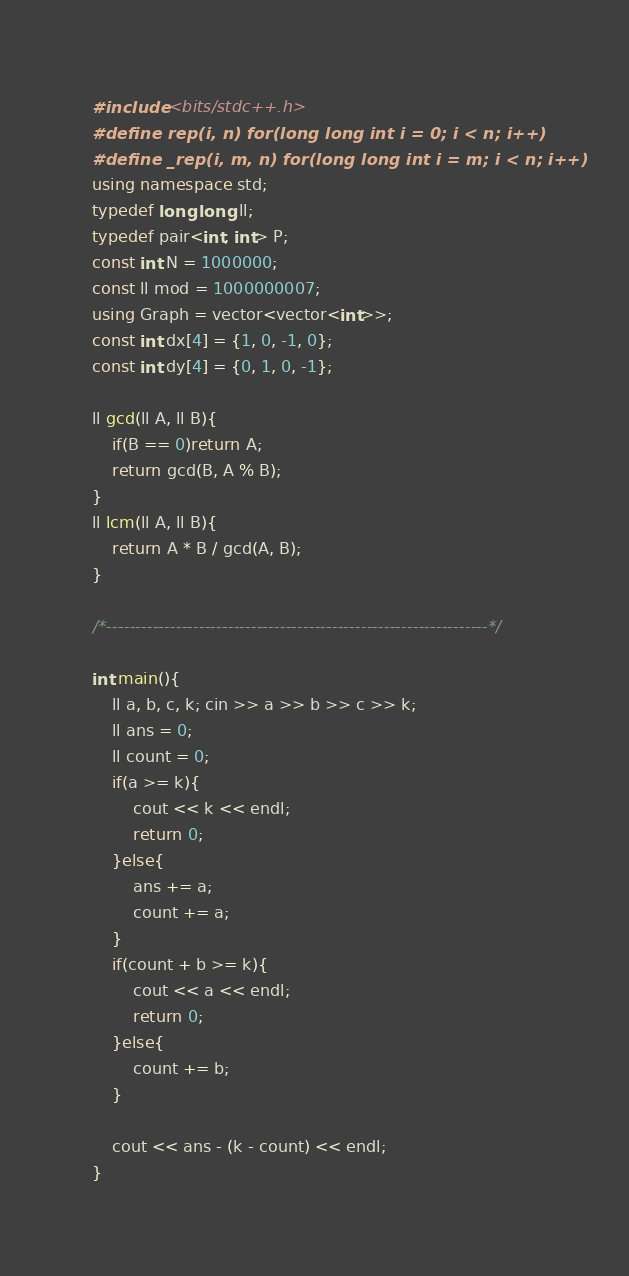Convert code to text. <code><loc_0><loc_0><loc_500><loc_500><_C++_>#include <bits/stdc++.h>
#define rep(i, n) for(long long int i = 0; i < n; i++)
#define _rep(i, m, n) for(long long int i = m; i < n; i++)
using namespace std;
typedef long long ll;
typedef pair<int, int> P;
const int N = 1000000;
const ll mod = 1000000007;
using Graph = vector<vector<int>>;
const int dx[4] = {1, 0, -1, 0};
const int dy[4] = {0, 1, 0, -1};

ll gcd(ll A, ll B){
    if(B == 0)return A;
    return gcd(B, A % B);
}
ll lcm(ll A, ll B){
    return A * B / gcd(A, B);
}

/*------------------------------------------------------------------*/

int main(){
    ll a, b, c, k; cin >> a >> b >> c >> k;
    ll ans = 0;
    ll count = 0;
    if(a >= k){
        cout << k << endl;
        return 0;
    }else{
        ans += a;
        count += a;
    }
    if(count + b >= k){
        cout << a << endl;
        return 0;
    }else{
        count += b;
    }

    cout << ans - (k - count) << endl;
}</code> 